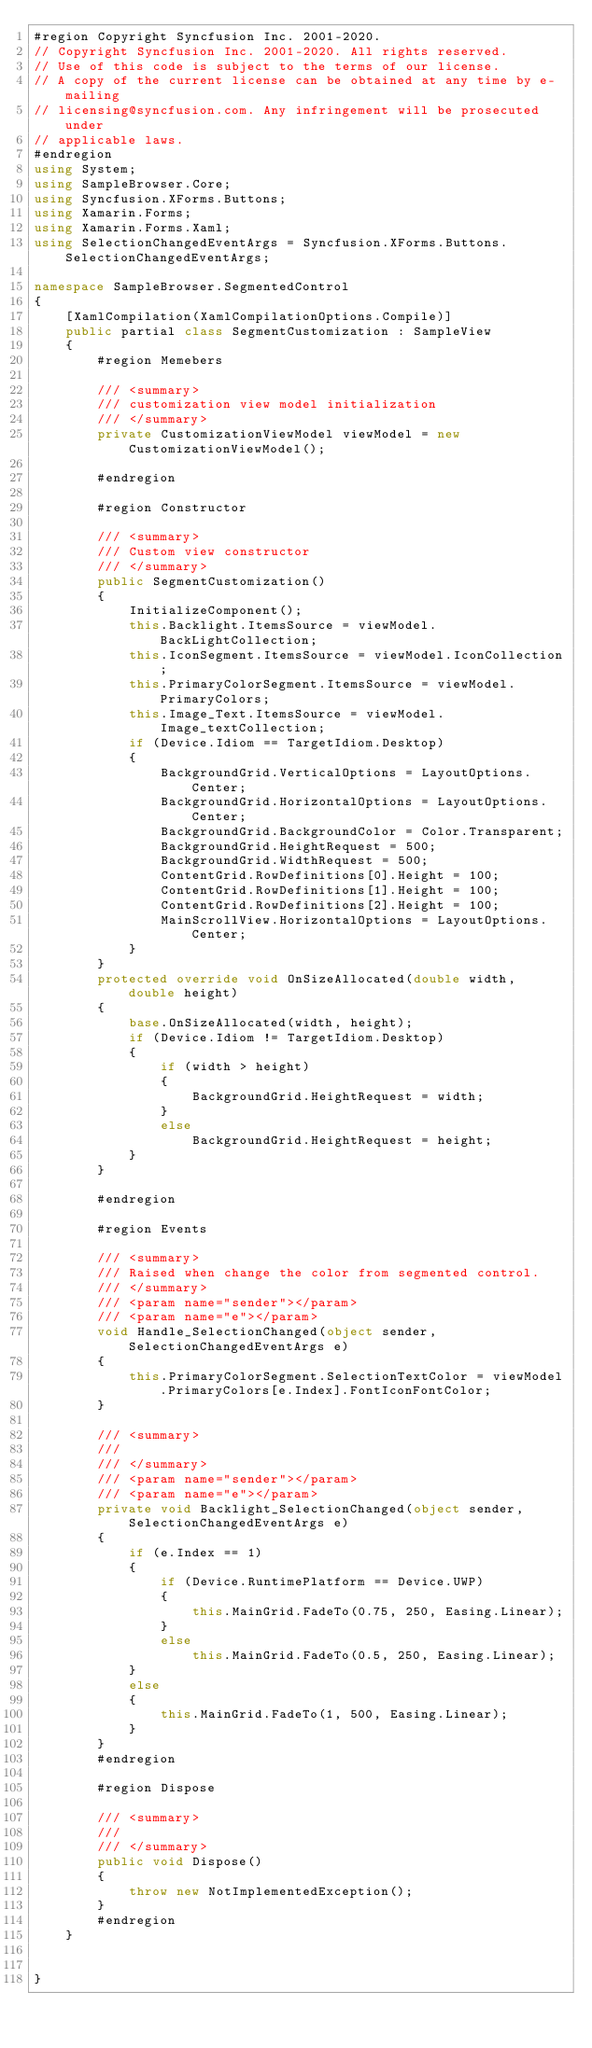Convert code to text. <code><loc_0><loc_0><loc_500><loc_500><_C#_>#region Copyright Syncfusion Inc. 2001-2020.
// Copyright Syncfusion Inc. 2001-2020. All rights reserved.
// Use of this code is subject to the terms of our license.
// A copy of the current license can be obtained at any time by e-mailing
// licensing@syncfusion.com. Any infringement will be prosecuted under
// applicable laws. 
#endregion
using System;
using SampleBrowser.Core;
using Syncfusion.XForms.Buttons;
using Xamarin.Forms;
using Xamarin.Forms.Xaml;
using SelectionChangedEventArgs = Syncfusion.XForms.Buttons.SelectionChangedEventArgs;

namespace SampleBrowser.SegmentedControl
{
    [XamlCompilation(XamlCompilationOptions.Compile)]
    public partial class SegmentCustomization : SampleView
    {
        #region Memebers

        /// <summary>
        /// customization view model initialization
        /// </summary>
        private CustomizationViewModel viewModel = new CustomizationViewModel();

        #endregion

        #region Constructor

        /// <summary>
        /// Custom view constructor
        /// </summary>
        public SegmentCustomization()
        {
            InitializeComponent();
            this.Backlight.ItemsSource = viewModel.BackLightCollection;
            this.IconSegment.ItemsSource = viewModel.IconCollection;
            this.PrimaryColorSegment.ItemsSource = viewModel.PrimaryColors;
            this.Image_Text.ItemsSource = viewModel.Image_textCollection;
            if (Device.Idiom == TargetIdiom.Desktop)
            {
                BackgroundGrid.VerticalOptions = LayoutOptions.Center;
                BackgroundGrid.HorizontalOptions = LayoutOptions.Center;
                BackgroundGrid.BackgroundColor = Color.Transparent;
                BackgroundGrid.HeightRequest = 500;
                BackgroundGrid.WidthRequest = 500;
                ContentGrid.RowDefinitions[0].Height = 100;
                ContentGrid.RowDefinitions[1].Height = 100;
                ContentGrid.RowDefinitions[2].Height = 100;          
                MainScrollView.HorizontalOptions = LayoutOptions.Center;
            }
        }
        protected override void OnSizeAllocated(double width, double height)
        {
            base.OnSizeAllocated(width, height);
            if (Device.Idiom != TargetIdiom.Desktop)
            {
                if (width > height)
                {
                    BackgroundGrid.HeightRequest = width;
                }
                else
                    BackgroundGrid.HeightRequest = height;
            }
        }

        #endregion

        #region Events

        /// <summary>
        /// Raised when change the color from segmented control.
        /// </summary>
        /// <param name="sender"></param>
        /// <param name="e"></param>
        void Handle_SelectionChanged(object sender, SelectionChangedEventArgs e)
        {
            this.PrimaryColorSegment.SelectionTextColor = viewModel.PrimaryColors[e.Index].FontIconFontColor;
        }

        /// <summary>
        /// 
        /// </summary>
        /// <param name="sender"></param>
        /// <param name="e"></param>
        private void Backlight_SelectionChanged(object sender, SelectionChangedEventArgs e)
        {
            if (e.Index == 1)
            {
                if (Device.RuntimePlatform == Device.UWP)
                {
                    this.MainGrid.FadeTo(0.75, 250, Easing.Linear);
                }
                else   
                    this.MainGrid.FadeTo(0.5, 250, Easing.Linear);
            }
            else
            {
                this.MainGrid.FadeTo(1, 500, Easing.Linear);
            }
        }
        #endregion

        #region Dispose

        /// <summary>
        /// 
        /// </summary>
        public void Dispose()
        {
            throw new NotImplementedException();
        }
        #endregion
    }


}</code> 